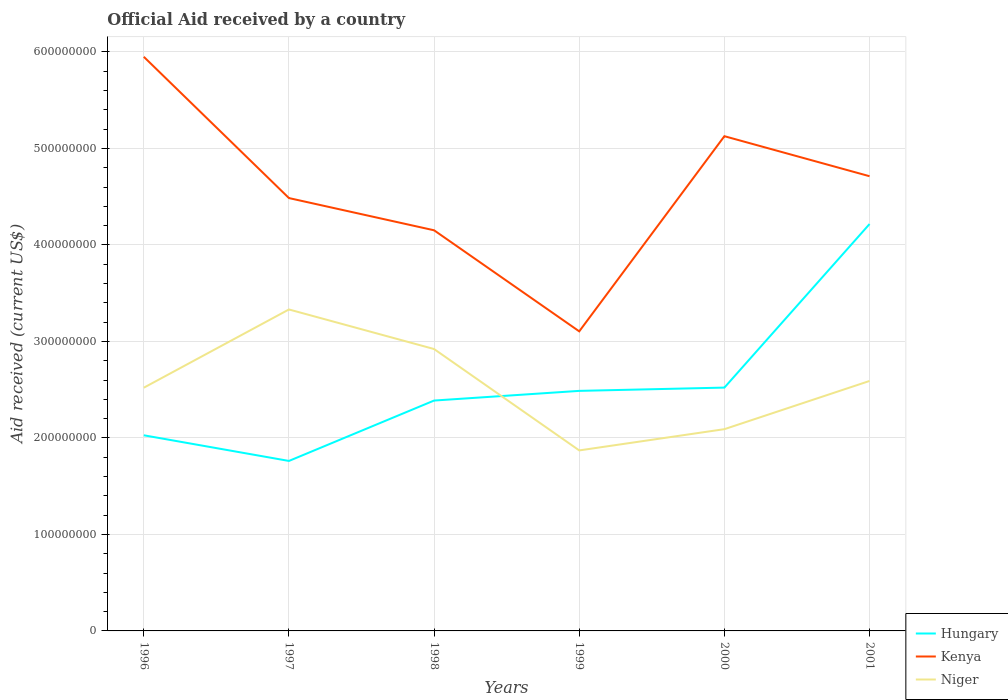How many different coloured lines are there?
Provide a short and direct response. 3. Across all years, what is the maximum net official aid received in Hungary?
Keep it short and to the point. 1.76e+08. What is the total net official aid received in Kenya in the graph?
Your answer should be very brief. -6.41e+07. What is the difference between the highest and the second highest net official aid received in Kenya?
Your answer should be very brief. 2.85e+08. Is the net official aid received in Niger strictly greater than the net official aid received in Kenya over the years?
Provide a short and direct response. Yes. How many lines are there?
Your answer should be compact. 3. How many years are there in the graph?
Your answer should be compact. 6. What is the difference between two consecutive major ticks on the Y-axis?
Your response must be concise. 1.00e+08. Does the graph contain grids?
Keep it short and to the point. Yes. Where does the legend appear in the graph?
Your answer should be compact. Bottom right. How many legend labels are there?
Your answer should be compact. 3. What is the title of the graph?
Your answer should be compact. Official Aid received by a country. Does "Uganda" appear as one of the legend labels in the graph?
Your answer should be very brief. No. What is the label or title of the Y-axis?
Provide a succinct answer. Aid received (current US$). What is the Aid received (current US$) in Hungary in 1996?
Keep it short and to the point. 2.03e+08. What is the Aid received (current US$) of Kenya in 1996?
Your response must be concise. 5.95e+08. What is the Aid received (current US$) of Niger in 1996?
Your answer should be compact. 2.52e+08. What is the Aid received (current US$) of Hungary in 1997?
Keep it short and to the point. 1.76e+08. What is the Aid received (current US$) of Kenya in 1997?
Offer a very short reply. 4.49e+08. What is the Aid received (current US$) of Niger in 1997?
Provide a short and direct response. 3.33e+08. What is the Aid received (current US$) of Hungary in 1998?
Offer a terse response. 2.39e+08. What is the Aid received (current US$) of Kenya in 1998?
Provide a short and direct response. 4.15e+08. What is the Aid received (current US$) in Niger in 1998?
Give a very brief answer. 2.92e+08. What is the Aid received (current US$) in Hungary in 1999?
Offer a terse response. 2.49e+08. What is the Aid received (current US$) of Kenya in 1999?
Provide a succinct answer. 3.10e+08. What is the Aid received (current US$) in Niger in 1999?
Your answer should be compact. 1.87e+08. What is the Aid received (current US$) in Hungary in 2000?
Your response must be concise. 2.52e+08. What is the Aid received (current US$) in Kenya in 2000?
Offer a terse response. 5.13e+08. What is the Aid received (current US$) of Niger in 2000?
Provide a short and direct response. 2.09e+08. What is the Aid received (current US$) of Hungary in 2001?
Your answer should be very brief. 4.22e+08. What is the Aid received (current US$) in Kenya in 2001?
Your response must be concise. 4.71e+08. What is the Aid received (current US$) in Niger in 2001?
Ensure brevity in your answer.  2.59e+08. Across all years, what is the maximum Aid received (current US$) of Hungary?
Provide a short and direct response. 4.22e+08. Across all years, what is the maximum Aid received (current US$) of Kenya?
Offer a terse response. 5.95e+08. Across all years, what is the maximum Aid received (current US$) of Niger?
Keep it short and to the point. 3.33e+08. Across all years, what is the minimum Aid received (current US$) of Hungary?
Keep it short and to the point. 1.76e+08. Across all years, what is the minimum Aid received (current US$) of Kenya?
Offer a terse response. 3.10e+08. Across all years, what is the minimum Aid received (current US$) in Niger?
Your answer should be very brief. 1.87e+08. What is the total Aid received (current US$) in Hungary in the graph?
Your answer should be compact. 1.54e+09. What is the total Aid received (current US$) of Kenya in the graph?
Keep it short and to the point. 2.75e+09. What is the total Aid received (current US$) of Niger in the graph?
Ensure brevity in your answer.  1.53e+09. What is the difference between the Aid received (current US$) in Hungary in 1996 and that in 1997?
Provide a succinct answer. 2.66e+07. What is the difference between the Aid received (current US$) in Kenya in 1996 and that in 1997?
Your answer should be compact. 1.46e+08. What is the difference between the Aid received (current US$) of Niger in 1996 and that in 1997?
Give a very brief answer. -8.11e+07. What is the difference between the Aid received (current US$) of Hungary in 1996 and that in 1998?
Offer a terse response. -3.60e+07. What is the difference between the Aid received (current US$) of Kenya in 1996 and that in 1998?
Your answer should be very brief. 1.80e+08. What is the difference between the Aid received (current US$) of Niger in 1996 and that in 1998?
Ensure brevity in your answer.  -4.01e+07. What is the difference between the Aid received (current US$) in Hungary in 1996 and that in 1999?
Give a very brief answer. -4.60e+07. What is the difference between the Aid received (current US$) in Kenya in 1996 and that in 1999?
Ensure brevity in your answer.  2.85e+08. What is the difference between the Aid received (current US$) of Niger in 1996 and that in 1999?
Your answer should be compact. 6.50e+07. What is the difference between the Aid received (current US$) of Hungary in 1996 and that in 2000?
Give a very brief answer. -4.94e+07. What is the difference between the Aid received (current US$) of Kenya in 1996 and that in 2000?
Provide a succinct answer. 8.23e+07. What is the difference between the Aid received (current US$) in Niger in 1996 and that in 2000?
Make the answer very short. 4.30e+07. What is the difference between the Aid received (current US$) of Hungary in 1996 and that in 2001?
Your response must be concise. -2.19e+08. What is the difference between the Aid received (current US$) of Kenya in 1996 and that in 2001?
Your answer should be very brief. 1.24e+08. What is the difference between the Aid received (current US$) in Niger in 1996 and that in 2001?
Keep it short and to the point. -6.99e+06. What is the difference between the Aid received (current US$) in Hungary in 1997 and that in 1998?
Make the answer very short. -6.26e+07. What is the difference between the Aid received (current US$) of Kenya in 1997 and that in 1998?
Your response must be concise. 3.34e+07. What is the difference between the Aid received (current US$) of Niger in 1997 and that in 1998?
Give a very brief answer. 4.10e+07. What is the difference between the Aid received (current US$) in Hungary in 1997 and that in 1999?
Offer a very short reply. -7.26e+07. What is the difference between the Aid received (current US$) of Kenya in 1997 and that in 1999?
Provide a succinct answer. 1.38e+08. What is the difference between the Aid received (current US$) of Niger in 1997 and that in 1999?
Give a very brief answer. 1.46e+08. What is the difference between the Aid received (current US$) of Hungary in 1997 and that in 2000?
Keep it short and to the point. -7.60e+07. What is the difference between the Aid received (current US$) of Kenya in 1997 and that in 2000?
Make the answer very short. -6.41e+07. What is the difference between the Aid received (current US$) of Niger in 1997 and that in 2000?
Make the answer very short. 1.24e+08. What is the difference between the Aid received (current US$) of Hungary in 1997 and that in 2001?
Provide a short and direct response. -2.46e+08. What is the difference between the Aid received (current US$) of Kenya in 1997 and that in 2001?
Ensure brevity in your answer.  -2.26e+07. What is the difference between the Aid received (current US$) of Niger in 1997 and that in 2001?
Provide a succinct answer. 7.41e+07. What is the difference between the Aid received (current US$) of Hungary in 1998 and that in 1999?
Give a very brief answer. -1.00e+07. What is the difference between the Aid received (current US$) in Kenya in 1998 and that in 1999?
Offer a terse response. 1.05e+08. What is the difference between the Aid received (current US$) of Niger in 1998 and that in 1999?
Make the answer very short. 1.05e+08. What is the difference between the Aid received (current US$) of Hungary in 1998 and that in 2000?
Provide a short and direct response. -1.34e+07. What is the difference between the Aid received (current US$) in Kenya in 1998 and that in 2000?
Your answer should be compact. -9.75e+07. What is the difference between the Aid received (current US$) of Niger in 1998 and that in 2000?
Keep it short and to the point. 8.30e+07. What is the difference between the Aid received (current US$) of Hungary in 1998 and that in 2001?
Your response must be concise. -1.83e+08. What is the difference between the Aid received (current US$) in Kenya in 1998 and that in 2001?
Offer a terse response. -5.60e+07. What is the difference between the Aid received (current US$) of Niger in 1998 and that in 2001?
Make the answer very short. 3.31e+07. What is the difference between the Aid received (current US$) in Hungary in 1999 and that in 2000?
Provide a succinct answer. -3.39e+06. What is the difference between the Aid received (current US$) in Kenya in 1999 and that in 2000?
Offer a terse response. -2.02e+08. What is the difference between the Aid received (current US$) of Niger in 1999 and that in 2000?
Your answer should be compact. -2.20e+07. What is the difference between the Aid received (current US$) in Hungary in 1999 and that in 2001?
Provide a short and direct response. -1.73e+08. What is the difference between the Aid received (current US$) in Kenya in 1999 and that in 2001?
Provide a short and direct response. -1.61e+08. What is the difference between the Aid received (current US$) of Niger in 1999 and that in 2001?
Offer a terse response. -7.20e+07. What is the difference between the Aid received (current US$) of Hungary in 2000 and that in 2001?
Provide a succinct answer. -1.70e+08. What is the difference between the Aid received (current US$) in Kenya in 2000 and that in 2001?
Your answer should be very brief. 4.15e+07. What is the difference between the Aid received (current US$) in Niger in 2000 and that in 2001?
Your response must be concise. -5.00e+07. What is the difference between the Aid received (current US$) in Hungary in 1996 and the Aid received (current US$) in Kenya in 1997?
Keep it short and to the point. -2.46e+08. What is the difference between the Aid received (current US$) of Hungary in 1996 and the Aid received (current US$) of Niger in 1997?
Keep it short and to the point. -1.30e+08. What is the difference between the Aid received (current US$) in Kenya in 1996 and the Aid received (current US$) in Niger in 1997?
Your answer should be very brief. 2.62e+08. What is the difference between the Aid received (current US$) of Hungary in 1996 and the Aid received (current US$) of Kenya in 1998?
Offer a terse response. -2.12e+08. What is the difference between the Aid received (current US$) of Hungary in 1996 and the Aid received (current US$) of Niger in 1998?
Your answer should be compact. -8.94e+07. What is the difference between the Aid received (current US$) of Kenya in 1996 and the Aid received (current US$) of Niger in 1998?
Provide a short and direct response. 3.03e+08. What is the difference between the Aid received (current US$) in Hungary in 1996 and the Aid received (current US$) in Kenya in 1999?
Your response must be concise. -1.08e+08. What is the difference between the Aid received (current US$) in Hungary in 1996 and the Aid received (current US$) in Niger in 1999?
Offer a very short reply. 1.57e+07. What is the difference between the Aid received (current US$) of Kenya in 1996 and the Aid received (current US$) of Niger in 1999?
Ensure brevity in your answer.  4.08e+08. What is the difference between the Aid received (current US$) of Hungary in 1996 and the Aid received (current US$) of Kenya in 2000?
Your answer should be very brief. -3.10e+08. What is the difference between the Aid received (current US$) in Hungary in 1996 and the Aid received (current US$) in Niger in 2000?
Keep it short and to the point. -6.33e+06. What is the difference between the Aid received (current US$) of Kenya in 1996 and the Aid received (current US$) of Niger in 2000?
Offer a terse response. 3.86e+08. What is the difference between the Aid received (current US$) of Hungary in 1996 and the Aid received (current US$) of Kenya in 2001?
Make the answer very short. -2.68e+08. What is the difference between the Aid received (current US$) in Hungary in 1996 and the Aid received (current US$) in Niger in 2001?
Give a very brief answer. -5.63e+07. What is the difference between the Aid received (current US$) of Kenya in 1996 and the Aid received (current US$) of Niger in 2001?
Provide a short and direct response. 3.36e+08. What is the difference between the Aid received (current US$) of Hungary in 1997 and the Aid received (current US$) of Kenya in 1998?
Make the answer very short. -2.39e+08. What is the difference between the Aid received (current US$) of Hungary in 1997 and the Aid received (current US$) of Niger in 1998?
Your response must be concise. -1.16e+08. What is the difference between the Aid received (current US$) in Kenya in 1997 and the Aid received (current US$) in Niger in 1998?
Your answer should be very brief. 1.56e+08. What is the difference between the Aid received (current US$) in Hungary in 1997 and the Aid received (current US$) in Kenya in 1999?
Your answer should be compact. -1.34e+08. What is the difference between the Aid received (current US$) in Hungary in 1997 and the Aid received (current US$) in Niger in 1999?
Keep it short and to the point. -1.09e+07. What is the difference between the Aid received (current US$) of Kenya in 1997 and the Aid received (current US$) of Niger in 1999?
Keep it short and to the point. 2.62e+08. What is the difference between the Aid received (current US$) in Hungary in 1997 and the Aid received (current US$) in Kenya in 2000?
Your response must be concise. -3.37e+08. What is the difference between the Aid received (current US$) of Hungary in 1997 and the Aid received (current US$) of Niger in 2000?
Ensure brevity in your answer.  -3.29e+07. What is the difference between the Aid received (current US$) of Kenya in 1997 and the Aid received (current US$) of Niger in 2000?
Ensure brevity in your answer.  2.40e+08. What is the difference between the Aid received (current US$) in Hungary in 1997 and the Aid received (current US$) in Kenya in 2001?
Make the answer very short. -2.95e+08. What is the difference between the Aid received (current US$) in Hungary in 1997 and the Aid received (current US$) in Niger in 2001?
Ensure brevity in your answer.  -8.29e+07. What is the difference between the Aid received (current US$) in Kenya in 1997 and the Aid received (current US$) in Niger in 2001?
Your answer should be very brief. 1.90e+08. What is the difference between the Aid received (current US$) of Hungary in 1998 and the Aid received (current US$) of Kenya in 1999?
Offer a very short reply. -7.17e+07. What is the difference between the Aid received (current US$) in Hungary in 1998 and the Aid received (current US$) in Niger in 1999?
Make the answer very short. 5.17e+07. What is the difference between the Aid received (current US$) in Kenya in 1998 and the Aid received (current US$) in Niger in 1999?
Make the answer very short. 2.28e+08. What is the difference between the Aid received (current US$) of Hungary in 1998 and the Aid received (current US$) of Kenya in 2000?
Keep it short and to the point. -2.74e+08. What is the difference between the Aid received (current US$) in Hungary in 1998 and the Aid received (current US$) in Niger in 2000?
Offer a terse response. 2.97e+07. What is the difference between the Aid received (current US$) in Kenya in 1998 and the Aid received (current US$) in Niger in 2000?
Your answer should be compact. 2.06e+08. What is the difference between the Aid received (current US$) of Hungary in 1998 and the Aid received (current US$) of Kenya in 2001?
Provide a succinct answer. -2.32e+08. What is the difference between the Aid received (current US$) of Hungary in 1998 and the Aid received (current US$) of Niger in 2001?
Offer a very short reply. -2.03e+07. What is the difference between the Aid received (current US$) of Kenya in 1998 and the Aid received (current US$) of Niger in 2001?
Offer a very short reply. 1.56e+08. What is the difference between the Aid received (current US$) in Hungary in 1999 and the Aid received (current US$) in Kenya in 2000?
Give a very brief answer. -2.64e+08. What is the difference between the Aid received (current US$) of Hungary in 1999 and the Aid received (current US$) of Niger in 2000?
Offer a terse response. 3.97e+07. What is the difference between the Aid received (current US$) in Kenya in 1999 and the Aid received (current US$) in Niger in 2000?
Offer a very short reply. 1.01e+08. What is the difference between the Aid received (current US$) of Hungary in 1999 and the Aid received (current US$) of Kenya in 2001?
Offer a terse response. -2.22e+08. What is the difference between the Aid received (current US$) in Hungary in 1999 and the Aid received (current US$) in Niger in 2001?
Your response must be concise. -1.03e+07. What is the difference between the Aid received (current US$) in Kenya in 1999 and the Aid received (current US$) in Niger in 2001?
Provide a short and direct response. 5.14e+07. What is the difference between the Aid received (current US$) in Hungary in 2000 and the Aid received (current US$) in Kenya in 2001?
Your response must be concise. -2.19e+08. What is the difference between the Aid received (current US$) of Hungary in 2000 and the Aid received (current US$) of Niger in 2001?
Offer a terse response. -6.88e+06. What is the difference between the Aid received (current US$) of Kenya in 2000 and the Aid received (current US$) of Niger in 2001?
Your answer should be compact. 2.54e+08. What is the average Aid received (current US$) of Hungary per year?
Your answer should be compact. 2.57e+08. What is the average Aid received (current US$) of Kenya per year?
Offer a terse response. 4.59e+08. What is the average Aid received (current US$) of Niger per year?
Make the answer very short. 2.55e+08. In the year 1996, what is the difference between the Aid received (current US$) in Hungary and Aid received (current US$) in Kenya?
Provide a short and direct response. -3.92e+08. In the year 1996, what is the difference between the Aid received (current US$) of Hungary and Aid received (current US$) of Niger?
Offer a very short reply. -4.93e+07. In the year 1996, what is the difference between the Aid received (current US$) in Kenya and Aid received (current US$) in Niger?
Give a very brief answer. 3.43e+08. In the year 1997, what is the difference between the Aid received (current US$) of Hungary and Aid received (current US$) of Kenya?
Make the answer very short. -2.72e+08. In the year 1997, what is the difference between the Aid received (current US$) in Hungary and Aid received (current US$) in Niger?
Provide a succinct answer. -1.57e+08. In the year 1997, what is the difference between the Aid received (current US$) in Kenya and Aid received (current US$) in Niger?
Your answer should be very brief. 1.15e+08. In the year 1998, what is the difference between the Aid received (current US$) in Hungary and Aid received (current US$) in Kenya?
Keep it short and to the point. -1.76e+08. In the year 1998, what is the difference between the Aid received (current US$) of Hungary and Aid received (current US$) of Niger?
Give a very brief answer. -5.34e+07. In the year 1998, what is the difference between the Aid received (current US$) of Kenya and Aid received (current US$) of Niger?
Make the answer very short. 1.23e+08. In the year 1999, what is the difference between the Aid received (current US$) in Hungary and Aid received (current US$) in Kenya?
Offer a terse response. -6.17e+07. In the year 1999, what is the difference between the Aid received (current US$) of Hungary and Aid received (current US$) of Niger?
Ensure brevity in your answer.  6.17e+07. In the year 1999, what is the difference between the Aid received (current US$) in Kenya and Aid received (current US$) in Niger?
Offer a terse response. 1.23e+08. In the year 2000, what is the difference between the Aid received (current US$) in Hungary and Aid received (current US$) in Kenya?
Your answer should be compact. -2.61e+08. In the year 2000, what is the difference between the Aid received (current US$) in Hungary and Aid received (current US$) in Niger?
Provide a short and direct response. 4.31e+07. In the year 2000, what is the difference between the Aid received (current US$) of Kenya and Aid received (current US$) of Niger?
Give a very brief answer. 3.04e+08. In the year 2001, what is the difference between the Aid received (current US$) in Hungary and Aid received (current US$) in Kenya?
Provide a succinct answer. -4.95e+07. In the year 2001, what is the difference between the Aid received (current US$) of Hungary and Aid received (current US$) of Niger?
Offer a very short reply. 1.63e+08. In the year 2001, what is the difference between the Aid received (current US$) of Kenya and Aid received (current US$) of Niger?
Keep it short and to the point. 2.12e+08. What is the ratio of the Aid received (current US$) of Hungary in 1996 to that in 1997?
Your response must be concise. 1.15. What is the ratio of the Aid received (current US$) in Kenya in 1996 to that in 1997?
Offer a terse response. 1.33. What is the ratio of the Aid received (current US$) in Niger in 1996 to that in 1997?
Ensure brevity in your answer.  0.76. What is the ratio of the Aid received (current US$) of Hungary in 1996 to that in 1998?
Provide a succinct answer. 0.85. What is the ratio of the Aid received (current US$) in Kenya in 1996 to that in 1998?
Offer a terse response. 1.43. What is the ratio of the Aid received (current US$) of Niger in 1996 to that in 1998?
Your response must be concise. 0.86. What is the ratio of the Aid received (current US$) in Hungary in 1996 to that in 1999?
Make the answer very short. 0.81. What is the ratio of the Aid received (current US$) of Kenya in 1996 to that in 1999?
Provide a short and direct response. 1.92. What is the ratio of the Aid received (current US$) of Niger in 1996 to that in 1999?
Offer a terse response. 1.35. What is the ratio of the Aid received (current US$) of Hungary in 1996 to that in 2000?
Make the answer very short. 0.8. What is the ratio of the Aid received (current US$) in Kenya in 1996 to that in 2000?
Make the answer very short. 1.16. What is the ratio of the Aid received (current US$) of Niger in 1996 to that in 2000?
Your response must be concise. 1.21. What is the ratio of the Aid received (current US$) of Hungary in 1996 to that in 2001?
Your response must be concise. 0.48. What is the ratio of the Aid received (current US$) of Kenya in 1996 to that in 2001?
Your answer should be compact. 1.26. What is the ratio of the Aid received (current US$) in Hungary in 1997 to that in 1998?
Your response must be concise. 0.74. What is the ratio of the Aid received (current US$) in Kenya in 1997 to that in 1998?
Your answer should be compact. 1.08. What is the ratio of the Aid received (current US$) of Niger in 1997 to that in 1998?
Make the answer very short. 1.14. What is the ratio of the Aid received (current US$) of Hungary in 1997 to that in 1999?
Keep it short and to the point. 0.71. What is the ratio of the Aid received (current US$) of Kenya in 1997 to that in 1999?
Your answer should be very brief. 1.44. What is the ratio of the Aid received (current US$) in Niger in 1997 to that in 1999?
Your answer should be very brief. 1.78. What is the ratio of the Aid received (current US$) in Hungary in 1997 to that in 2000?
Keep it short and to the point. 0.7. What is the ratio of the Aid received (current US$) of Kenya in 1997 to that in 2000?
Your answer should be compact. 0.87. What is the ratio of the Aid received (current US$) of Niger in 1997 to that in 2000?
Your answer should be very brief. 1.59. What is the ratio of the Aid received (current US$) of Hungary in 1997 to that in 2001?
Offer a very short reply. 0.42. What is the ratio of the Aid received (current US$) in Kenya in 1997 to that in 2001?
Your answer should be very brief. 0.95. What is the ratio of the Aid received (current US$) in Niger in 1997 to that in 2001?
Offer a terse response. 1.29. What is the ratio of the Aid received (current US$) of Hungary in 1998 to that in 1999?
Give a very brief answer. 0.96. What is the ratio of the Aid received (current US$) of Kenya in 1998 to that in 1999?
Provide a short and direct response. 1.34. What is the ratio of the Aid received (current US$) of Niger in 1998 to that in 1999?
Provide a succinct answer. 1.56. What is the ratio of the Aid received (current US$) in Hungary in 1998 to that in 2000?
Give a very brief answer. 0.95. What is the ratio of the Aid received (current US$) of Kenya in 1998 to that in 2000?
Offer a very short reply. 0.81. What is the ratio of the Aid received (current US$) of Niger in 1998 to that in 2000?
Keep it short and to the point. 1.4. What is the ratio of the Aid received (current US$) in Hungary in 1998 to that in 2001?
Your answer should be very brief. 0.57. What is the ratio of the Aid received (current US$) of Kenya in 1998 to that in 2001?
Offer a very short reply. 0.88. What is the ratio of the Aid received (current US$) in Niger in 1998 to that in 2001?
Your answer should be very brief. 1.13. What is the ratio of the Aid received (current US$) of Hungary in 1999 to that in 2000?
Ensure brevity in your answer.  0.99. What is the ratio of the Aid received (current US$) of Kenya in 1999 to that in 2000?
Your response must be concise. 0.61. What is the ratio of the Aid received (current US$) of Niger in 1999 to that in 2000?
Your answer should be very brief. 0.89. What is the ratio of the Aid received (current US$) in Hungary in 1999 to that in 2001?
Your answer should be compact. 0.59. What is the ratio of the Aid received (current US$) of Kenya in 1999 to that in 2001?
Provide a succinct answer. 0.66. What is the ratio of the Aid received (current US$) of Niger in 1999 to that in 2001?
Ensure brevity in your answer.  0.72. What is the ratio of the Aid received (current US$) of Hungary in 2000 to that in 2001?
Your answer should be very brief. 0.6. What is the ratio of the Aid received (current US$) of Kenya in 2000 to that in 2001?
Offer a terse response. 1.09. What is the ratio of the Aid received (current US$) of Niger in 2000 to that in 2001?
Provide a short and direct response. 0.81. What is the difference between the highest and the second highest Aid received (current US$) in Hungary?
Provide a short and direct response. 1.70e+08. What is the difference between the highest and the second highest Aid received (current US$) in Kenya?
Give a very brief answer. 8.23e+07. What is the difference between the highest and the second highest Aid received (current US$) of Niger?
Keep it short and to the point. 4.10e+07. What is the difference between the highest and the lowest Aid received (current US$) in Hungary?
Provide a short and direct response. 2.46e+08. What is the difference between the highest and the lowest Aid received (current US$) of Kenya?
Ensure brevity in your answer.  2.85e+08. What is the difference between the highest and the lowest Aid received (current US$) in Niger?
Give a very brief answer. 1.46e+08. 